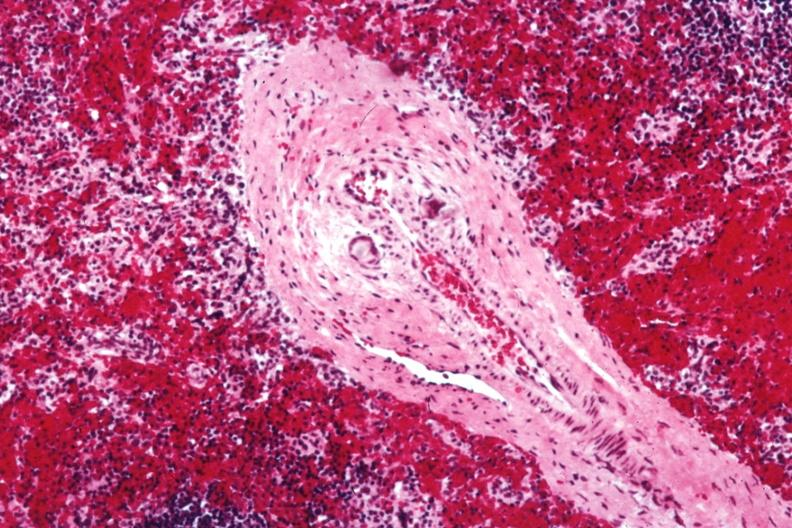what is giant cells in wall containing?
Answer the question using a single word or phrase. Crystalline material postoperative cardiac surgery thought to be silicon 